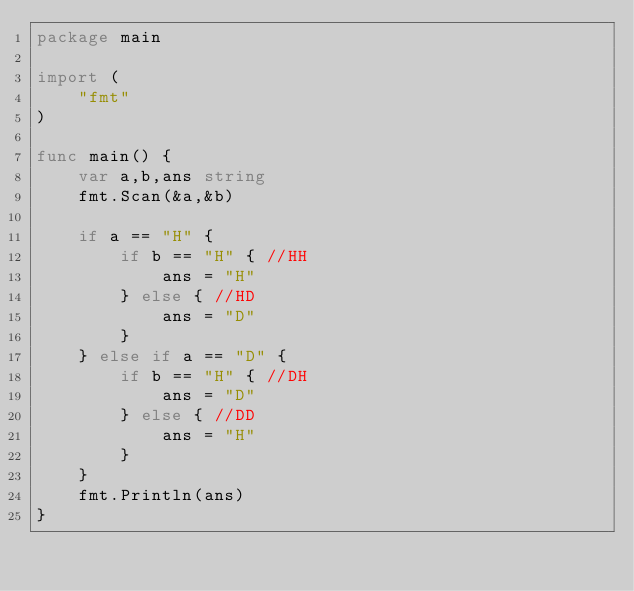<code> <loc_0><loc_0><loc_500><loc_500><_Go_>package main

import (
	"fmt"
)

func main() {
	var a,b,ans string
	fmt.Scan(&a,&b)
	
	if a == "H" { 
		if b == "H" { //HH
			ans = "H"
		} else { //HD
			ans = "D"
		}
	} else if a == "D" {
		if b == "H" { //DH
			ans = "D"
		} else { //DD
			ans = "H"
		}
	}
	fmt.Println(ans)
}</code> 